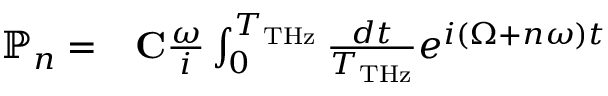Convert formula to latex. <formula><loc_0><loc_0><loc_500><loc_500>\begin{array} { r l } { \mathbb { P } _ { n } = } & { C } \frac { \omega } { i } \int _ { 0 } ^ { T _ { T H z } } \frac { d t } { T _ { T H z } } e ^ { i ( \Omega + n \omega ) t } } \end{array}</formula> 